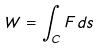<formula> <loc_0><loc_0><loc_500><loc_500>W = \int _ { C } F d s</formula> 